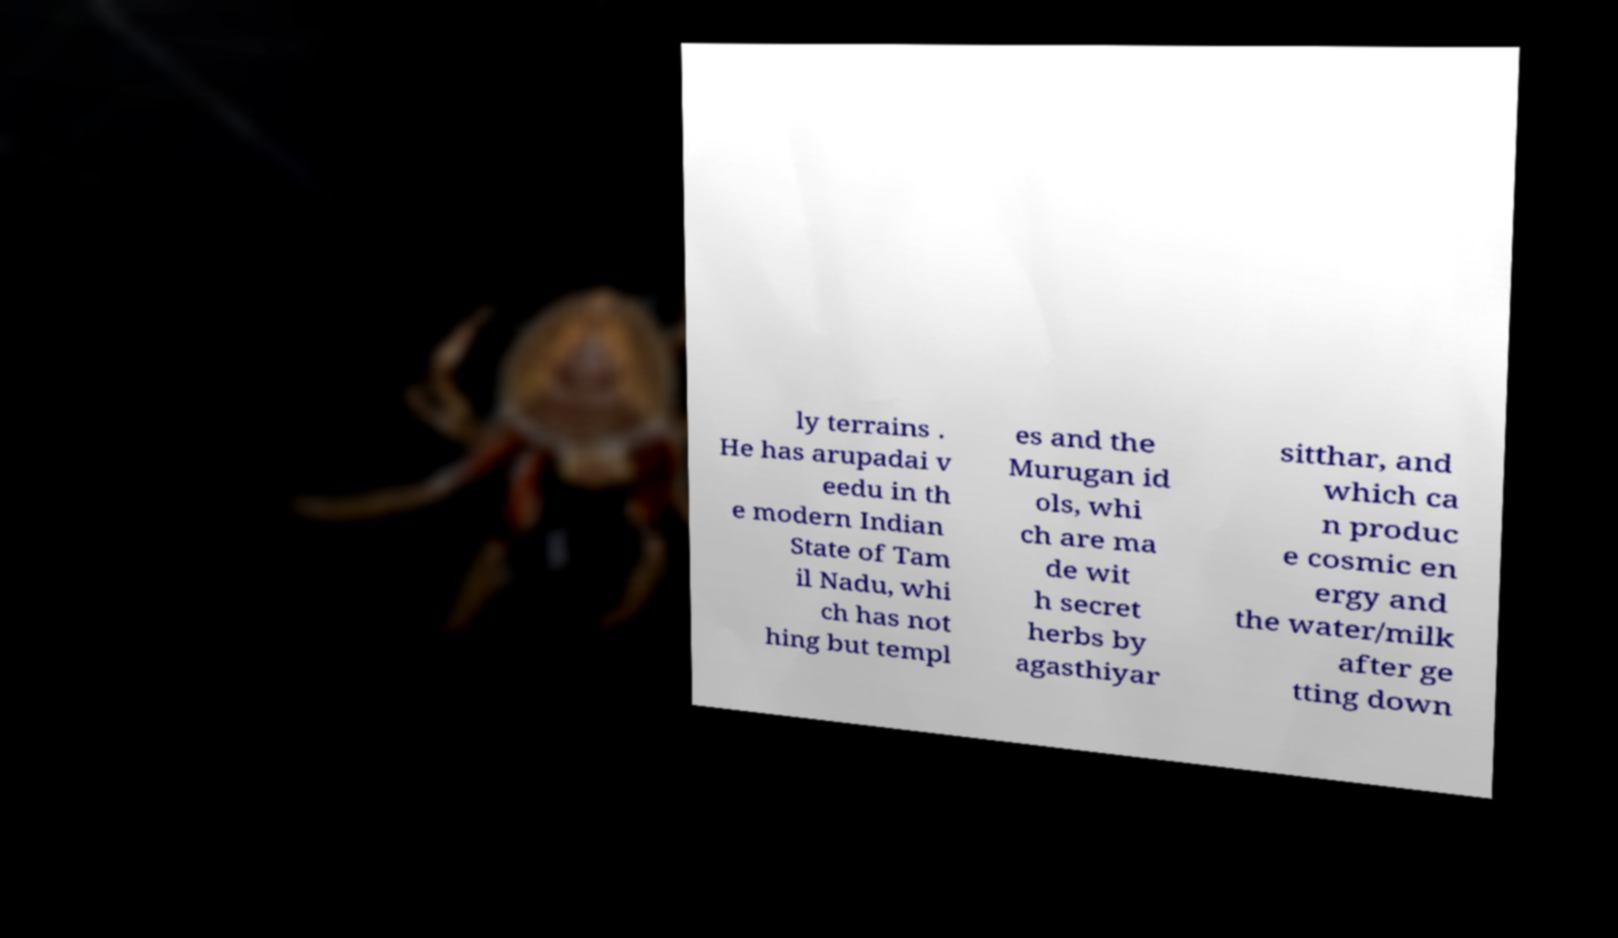What messages or text are displayed in this image? I need them in a readable, typed format. ly terrains . He has arupadai v eedu in th e modern Indian State of Tam il Nadu, whi ch has not hing but templ es and the Murugan id ols, whi ch are ma de wit h secret herbs by agasthiyar sitthar, and which ca n produc e cosmic en ergy and the water/milk after ge tting down 